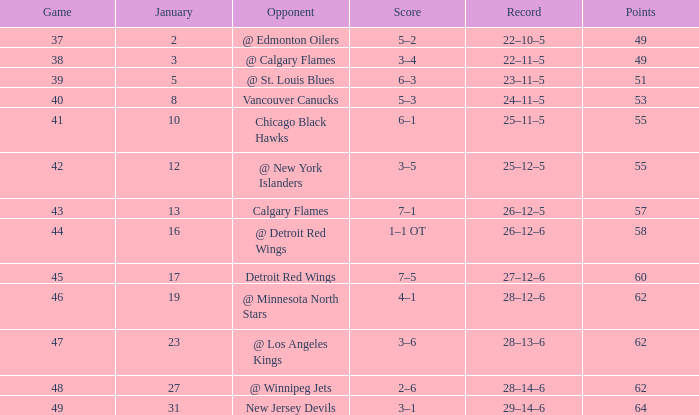Which Points have a Score of 4–1? 62.0. 